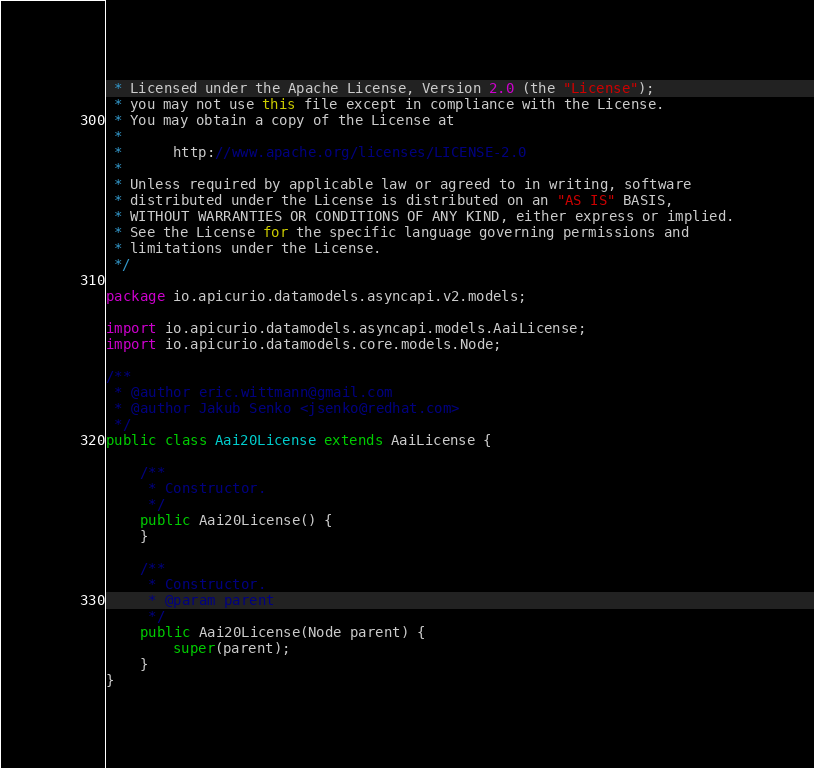Convert code to text. <code><loc_0><loc_0><loc_500><loc_500><_Java_> * Licensed under the Apache License, Version 2.0 (the "License");
 * you may not use this file except in compliance with the License.
 * You may obtain a copy of the License at
 *
 *      http://www.apache.org/licenses/LICENSE-2.0
 *
 * Unless required by applicable law or agreed to in writing, software
 * distributed under the License is distributed on an "AS IS" BASIS,
 * WITHOUT WARRANTIES OR CONDITIONS OF ANY KIND, either express or implied.
 * See the License for the specific language governing permissions and
 * limitations under the License.
 */

package io.apicurio.datamodels.asyncapi.v2.models;

import io.apicurio.datamodels.asyncapi.models.AaiLicense;
import io.apicurio.datamodels.core.models.Node;

/**
 * @author eric.wittmann@gmail.com
 * @author Jakub Senko <jsenko@redhat.com>
 */
public class Aai20License extends AaiLicense {

    /**
     * Constructor.
     */
    public Aai20License() {
    }
    
    /**
     * Constructor.
     * @param parent
     */
    public Aai20License(Node parent) {
        super(parent);
    }
}
</code> 